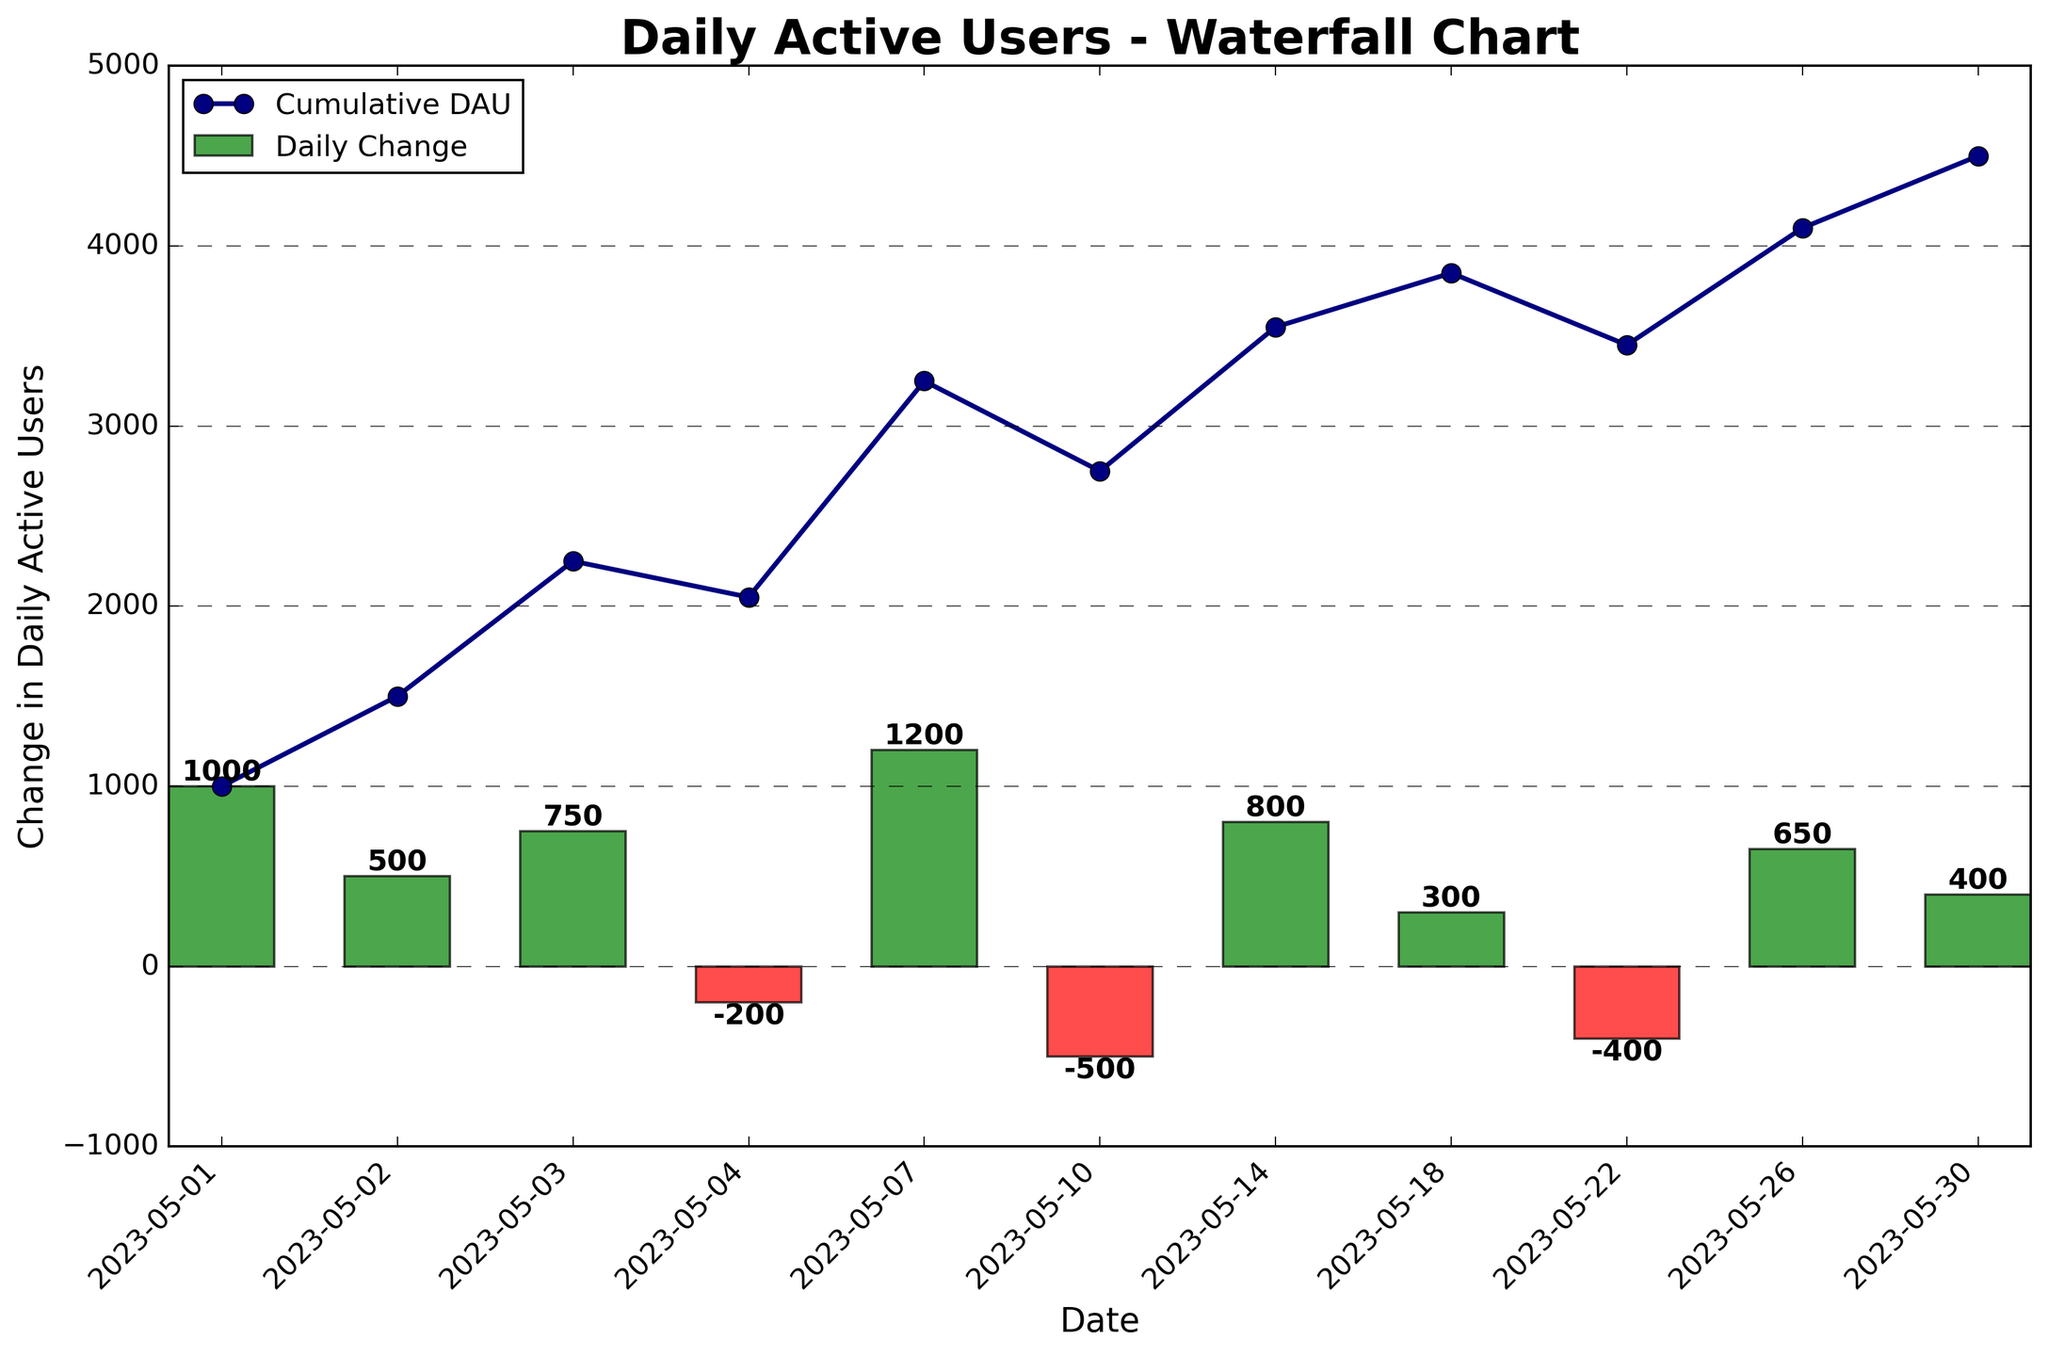What is the title of the chart? The title is displayed at the top of the chart in larger and bold font, and it reads "Daily Active Users - Waterfall Chart".
Answer: Daily Active Users - Waterfall Chart How many days showed a decrease in Daily Active Users (DAU)? To find the days with a decrease in DAU, count the bars with red color. There are three days (2023-05-04, 2023-05-10, and 2023-05-22) where the DAU decreased.
Answer: 3 Which day had the highest increase in DAU? Look for the bar with the highest positive value. The bar for 2023-05-07, which appears green and extends higher than the others, indicates the highest increase of 1200 DAUs.
Answer: 2023-05-07 What is the cumulative DAU on 2023-05-26? The cumulative DAU can be read from the line plot on the respective date. On 2023-05-26, the cumulative DAU is represented by the point at 4100.
Answer: 4100 On which date did the cumulative DAU first exceed 3000? Analyze the cumulative line plot and find the first point where the value crosses 3000. The cumulative DAU first exceeds 3000 on 2023-05-07 with a value of 3250.
Answer: 2023-05-07 What is the total change in DAU for the first 10 days? Sum up the change in DAU for all entries up to and including 2023-05-10: (1000 + 500 + 750 - 200 + 1200 - 500) = 2750.
Answer: 2750 Which date shows the smallest decrease in DAU and what is the value? Identify the red bars and find the one with the smallest (least negative) value. The date is 2023-05-04 with a decrease of 200 DAU.
Answer: 2023-05-04, -200 How many days had an increase of more than 500 DAU? Inspect the bars to count the ones exceeding 500 in height (positive value). The dates are 2023-05-01, 2023-05-03, 2023-05-07, 2023-05-14, and 2023-05-26, making a total of 5 days.
Answer: 5 What is the average increase in DAU over the entire month? Calculate the average of all positive changes: (1000 + 500 + 750 + 1200 + 800 + 300 + 650 + 400) / 8 = 5600 / 8 = 700
Answer: 700 Which date had the lowest cumulative DAU after an increase and what was the value? Find the lowest cumulative DAU value following a positive bar. The date is 2023-05-02 with a cumulative DAU of 1500 following an increase of 500.
Answer: 2023-05-02, 1500 